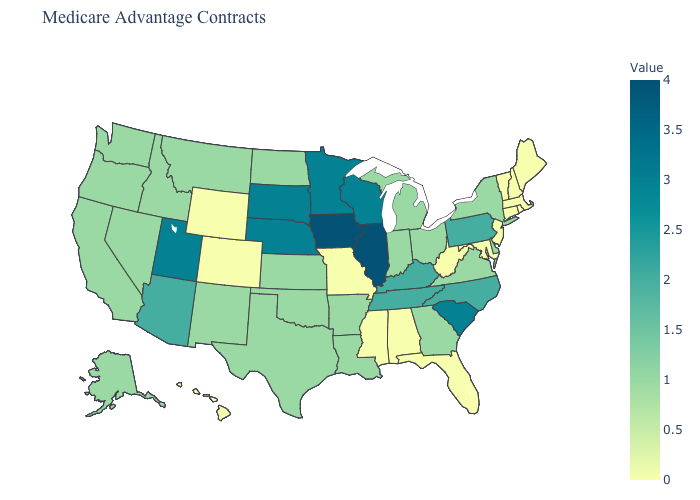Which states have the highest value in the USA?
Write a very short answer. Iowa, Illinois. Among the states that border Illinois , which have the highest value?
Write a very short answer. Iowa. Is the legend a continuous bar?
Be succinct. Yes. Does Illinois have the highest value in the USA?
Short answer required. Yes. Among the states that border Montana , which have the lowest value?
Answer briefly. Wyoming. Is the legend a continuous bar?
Write a very short answer. Yes. 